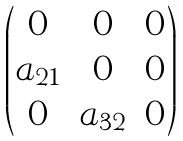<formula> <loc_0><loc_0><loc_500><loc_500>\begin{pmatrix} 0 & 0 & 0 \\ a _ { 2 1 } & 0 & 0 \\ 0 & a _ { 3 2 } & 0 \\ \end{pmatrix}</formula> 